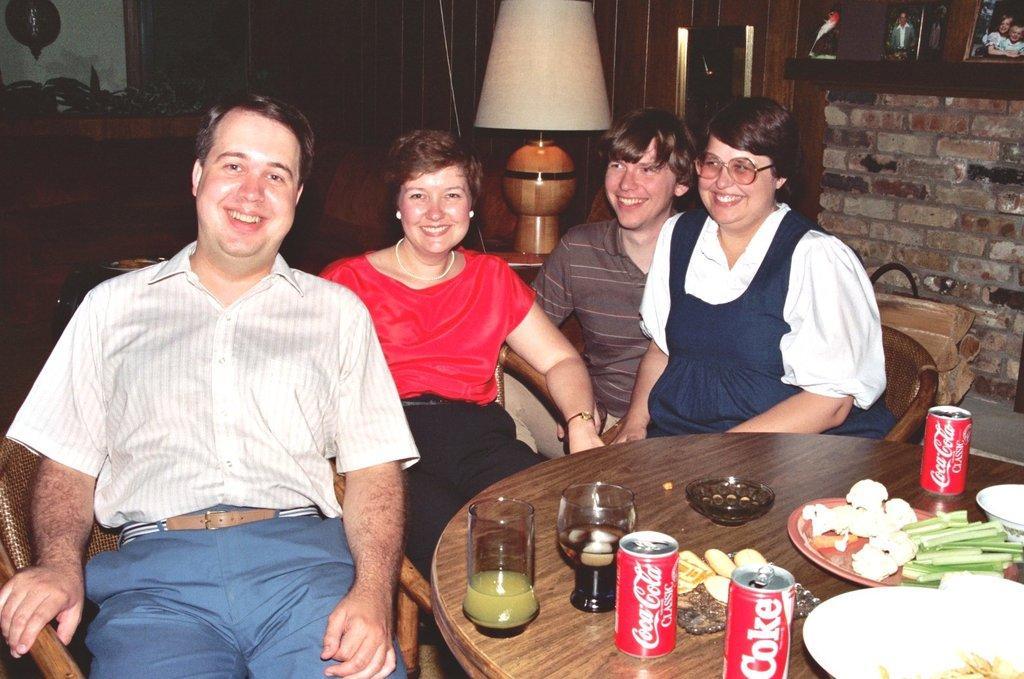How would you summarize this image in a sentence or two? In this image I can see four persons are sitting on the chairs in front of a table on which I can see bottles, glasses, plates, bowl and food items. In the background I can see a wall, lamp, photo frames, houseplants and a door. This image is taken may be in a room. 